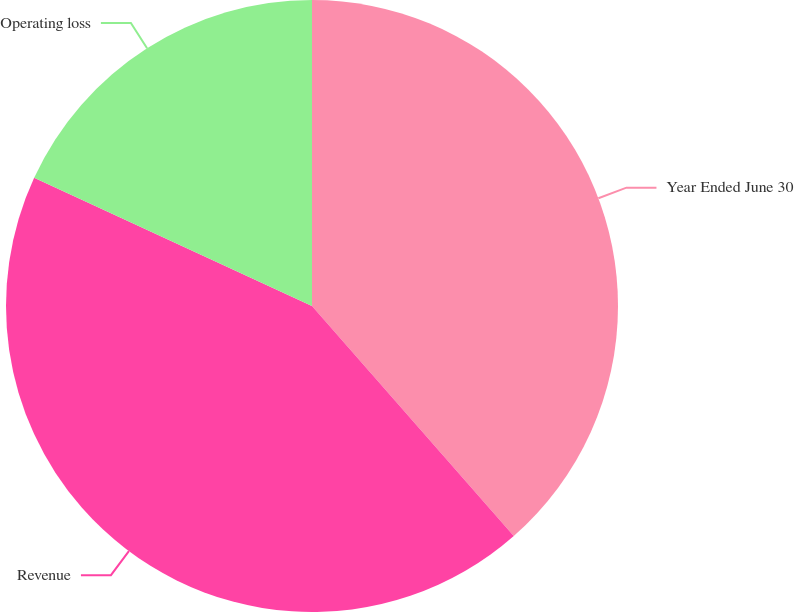<chart> <loc_0><loc_0><loc_500><loc_500><pie_chart><fcel>Year Ended June 30<fcel>Revenue<fcel>Operating loss<nl><fcel>38.54%<fcel>43.34%<fcel>18.12%<nl></chart> 